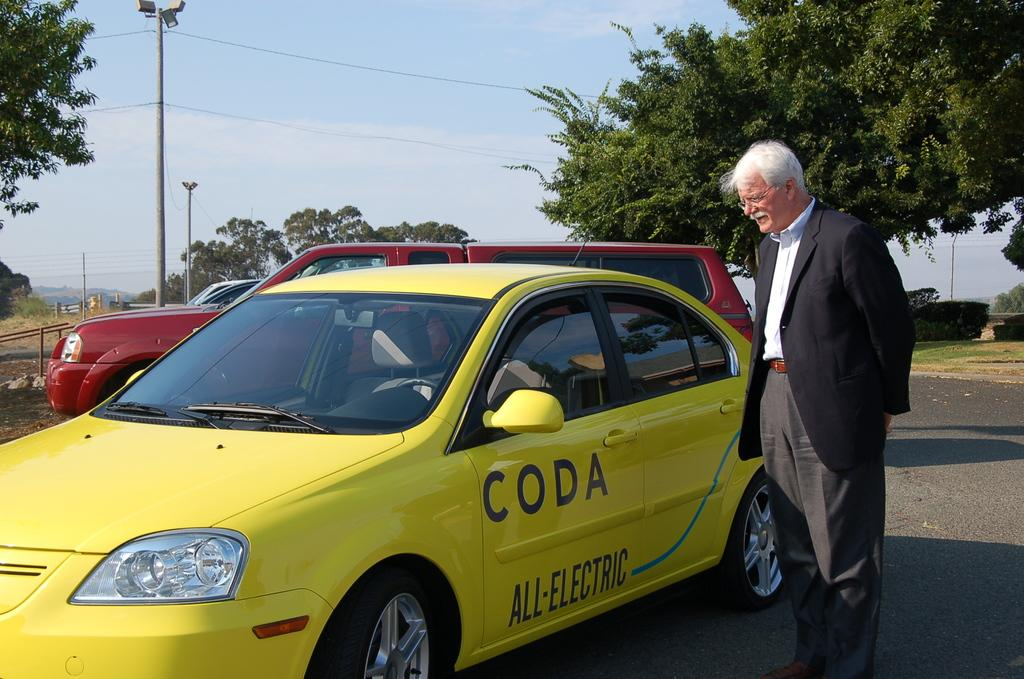<image>
Share a concise interpretation of the image provided. A man looks into a Coda All-Electric yellow car. 